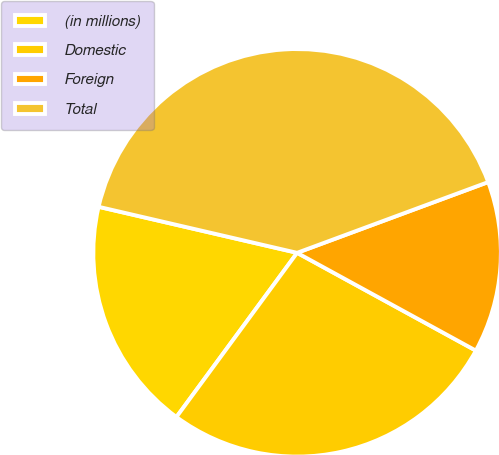Convert chart to OTSL. <chart><loc_0><loc_0><loc_500><loc_500><pie_chart><fcel>(in millions)<fcel>Domestic<fcel>Foreign<fcel>Total<nl><fcel>18.54%<fcel>27.12%<fcel>13.61%<fcel>40.73%<nl></chart> 